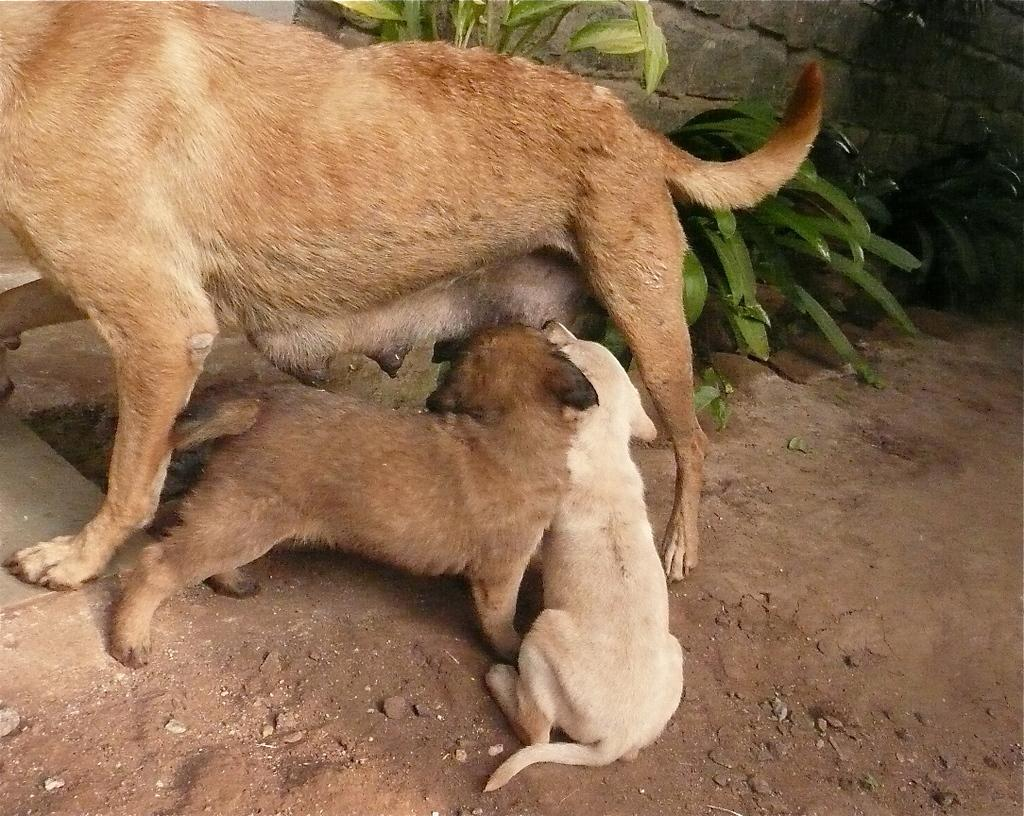What type of animal is present in the image? There is a dog in the image, along with two puppies. Where are the dog and puppies located? The dog and puppies are on the ground. What can be seen in the background of the image? There are plants and a wall in the background of the image. Can you determine the time of day the image was taken? The image was likely taken during the day, as there is sufficient light to see the dog, puppies, and background clearly. How many boys are playing with the baby bears in the image? There are no boys or baby bears present in the image; it features a dog and two puppies on the ground. 